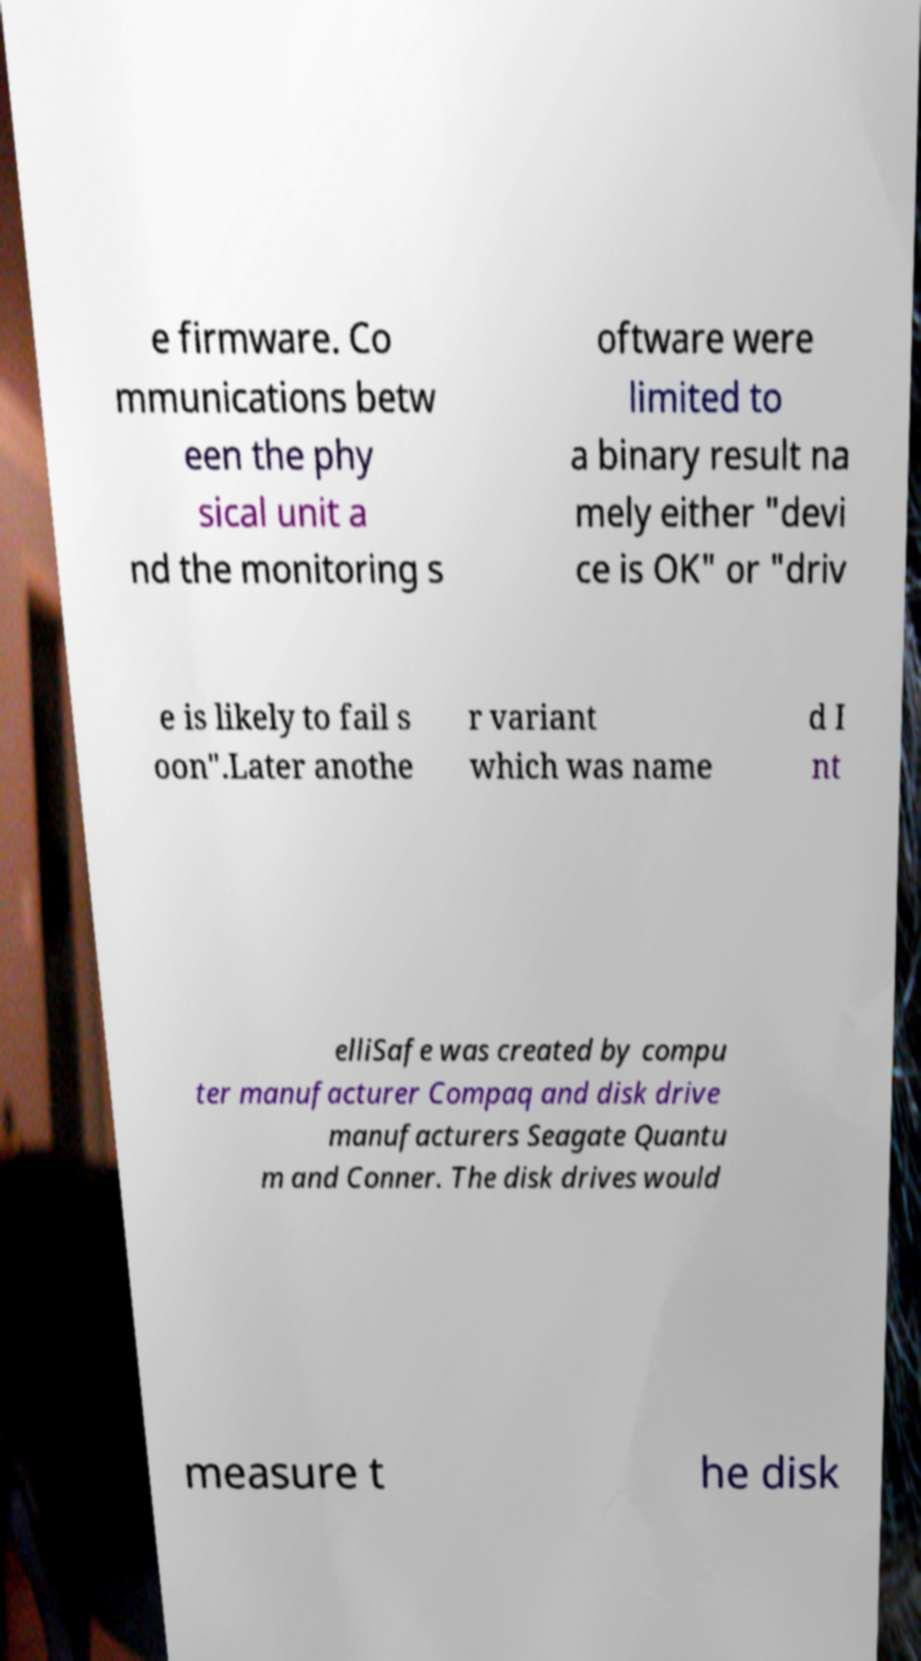Can you accurately transcribe the text from the provided image for me? e firmware. Co mmunications betw een the phy sical unit a nd the monitoring s oftware were limited to a binary result na mely either "devi ce is OK" or "driv e is likely to fail s oon".Later anothe r variant which was name d I nt elliSafe was created by compu ter manufacturer Compaq and disk drive manufacturers Seagate Quantu m and Conner. The disk drives would measure t he disk 